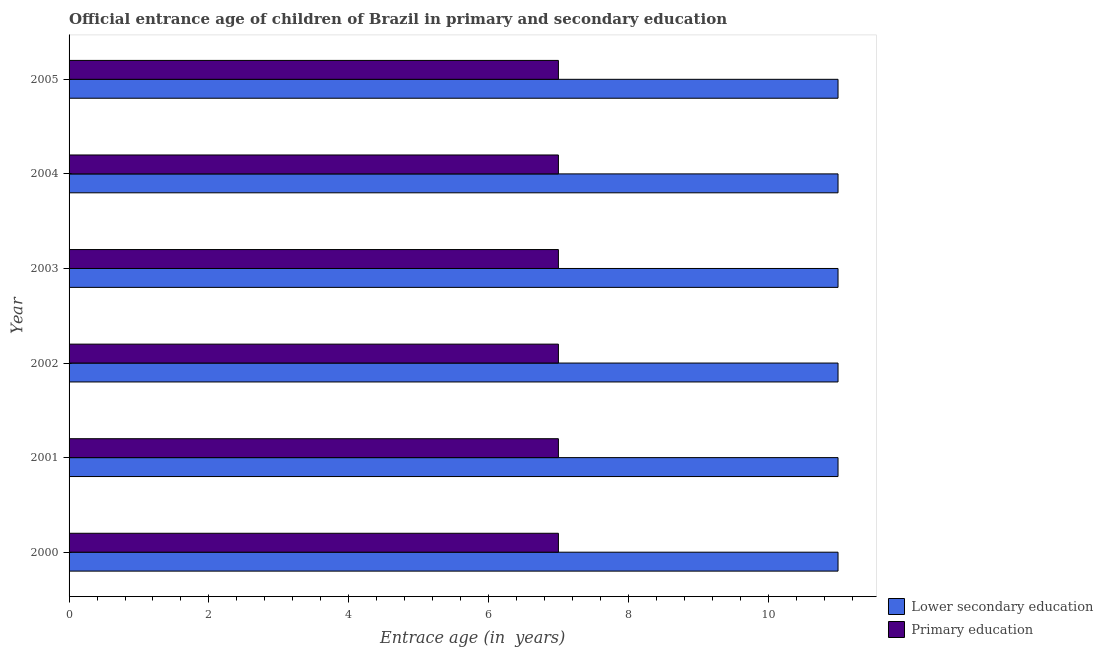How many different coloured bars are there?
Your response must be concise. 2. How many bars are there on the 5th tick from the top?
Offer a terse response. 2. How many bars are there on the 3rd tick from the bottom?
Keep it short and to the point. 2. In how many cases, is the number of bars for a given year not equal to the number of legend labels?
Your response must be concise. 0. What is the entrance age of chiildren in primary education in 2003?
Your answer should be very brief. 7. Across all years, what is the maximum entrance age of children in lower secondary education?
Your answer should be compact. 11. Across all years, what is the minimum entrance age of children in lower secondary education?
Provide a succinct answer. 11. In which year was the entrance age of children in lower secondary education maximum?
Keep it short and to the point. 2000. In which year was the entrance age of chiildren in primary education minimum?
Your answer should be compact. 2000. What is the total entrance age of children in lower secondary education in the graph?
Ensure brevity in your answer.  66. What is the difference between the entrance age of chiildren in primary education in 2001 and that in 2002?
Provide a succinct answer. 0. What is the difference between the entrance age of children in lower secondary education in 2000 and the entrance age of chiildren in primary education in 2004?
Make the answer very short. 4. What is the average entrance age of children in lower secondary education per year?
Your answer should be compact. 11. In the year 2005, what is the difference between the entrance age of children in lower secondary education and entrance age of chiildren in primary education?
Offer a very short reply. 4. In how many years, is the entrance age of chiildren in primary education greater than 2.4 years?
Provide a short and direct response. 6. Is the entrance age of chiildren in primary education in 2000 less than that in 2003?
Your response must be concise. No. What is the difference between the highest and the lowest entrance age of children in lower secondary education?
Make the answer very short. 0. How many years are there in the graph?
Offer a terse response. 6. What is the difference between two consecutive major ticks on the X-axis?
Your answer should be very brief. 2. Are the values on the major ticks of X-axis written in scientific E-notation?
Your response must be concise. No. Where does the legend appear in the graph?
Make the answer very short. Bottom right. How many legend labels are there?
Ensure brevity in your answer.  2. How are the legend labels stacked?
Provide a short and direct response. Vertical. What is the title of the graph?
Provide a succinct answer. Official entrance age of children of Brazil in primary and secondary education. What is the label or title of the X-axis?
Offer a terse response. Entrace age (in  years). What is the label or title of the Y-axis?
Your response must be concise. Year. What is the Entrace age (in  years) of Lower secondary education in 2000?
Give a very brief answer. 11. What is the Entrace age (in  years) in Primary education in 2002?
Provide a succinct answer. 7. What is the Entrace age (in  years) in Lower secondary education in 2003?
Your answer should be compact. 11. What is the Entrace age (in  years) in Primary education in 2003?
Your answer should be very brief. 7. Across all years, what is the maximum Entrace age (in  years) of Primary education?
Your response must be concise. 7. Across all years, what is the minimum Entrace age (in  years) of Lower secondary education?
Make the answer very short. 11. What is the total Entrace age (in  years) of Lower secondary education in the graph?
Keep it short and to the point. 66. What is the total Entrace age (in  years) in Primary education in the graph?
Make the answer very short. 42. What is the difference between the Entrace age (in  years) of Primary education in 2000 and that in 2001?
Your answer should be compact. 0. What is the difference between the Entrace age (in  years) of Primary education in 2000 and that in 2002?
Give a very brief answer. 0. What is the difference between the Entrace age (in  years) in Lower secondary education in 2000 and that in 2003?
Keep it short and to the point. 0. What is the difference between the Entrace age (in  years) of Primary education in 2000 and that in 2003?
Offer a very short reply. 0. What is the difference between the Entrace age (in  years) in Lower secondary education in 2000 and that in 2004?
Offer a very short reply. 0. What is the difference between the Entrace age (in  years) in Primary education in 2000 and that in 2005?
Give a very brief answer. 0. What is the difference between the Entrace age (in  years) in Primary education in 2001 and that in 2003?
Your response must be concise. 0. What is the difference between the Entrace age (in  years) of Lower secondary education in 2001 and that in 2005?
Provide a succinct answer. 0. What is the difference between the Entrace age (in  years) in Primary education in 2002 and that in 2003?
Your answer should be very brief. 0. What is the difference between the Entrace age (in  years) of Lower secondary education in 2003 and that in 2004?
Your answer should be compact. 0. What is the difference between the Entrace age (in  years) in Lower secondary education in 2003 and that in 2005?
Provide a succinct answer. 0. What is the difference between the Entrace age (in  years) in Lower secondary education in 2001 and the Entrace age (in  years) in Primary education in 2002?
Offer a very short reply. 4. What is the difference between the Entrace age (in  years) of Lower secondary education in 2001 and the Entrace age (in  years) of Primary education in 2005?
Keep it short and to the point. 4. What is the difference between the Entrace age (in  years) of Lower secondary education in 2002 and the Entrace age (in  years) of Primary education in 2003?
Your answer should be very brief. 4. What is the difference between the Entrace age (in  years) of Lower secondary education in 2002 and the Entrace age (in  years) of Primary education in 2004?
Your answer should be compact. 4. What is the difference between the Entrace age (in  years) in Lower secondary education in 2002 and the Entrace age (in  years) in Primary education in 2005?
Your response must be concise. 4. What is the difference between the Entrace age (in  years) in Lower secondary education in 2003 and the Entrace age (in  years) in Primary education in 2004?
Your response must be concise. 4. What is the difference between the Entrace age (in  years) in Lower secondary education in 2003 and the Entrace age (in  years) in Primary education in 2005?
Keep it short and to the point. 4. What is the difference between the Entrace age (in  years) in Lower secondary education in 2004 and the Entrace age (in  years) in Primary education in 2005?
Provide a short and direct response. 4. What is the average Entrace age (in  years) in Primary education per year?
Ensure brevity in your answer.  7. In the year 2002, what is the difference between the Entrace age (in  years) of Lower secondary education and Entrace age (in  years) of Primary education?
Your answer should be very brief. 4. In the year 2003, what is the difference between the Entrace age (in  years) of Lower secondary education and Entrace age (in  years) of Primary education?
Provide a short and direct response. 4. In the year 2004, what is the difference between the Entrace age (in  years) of Lower secondary education and Entrace age (in  years) of Primary education?
Keep it short and to the point. 4. What is the ratio of the Entrace age (in  years) of Lower secondary education in 2000 to that in 2002?
Provide a succinct answer. 1. What is the ratio of the Entrace age (in  years) in Lower secondary education in 2000 to that in 2003?
Give a very brief answer. 1. What is the ratio of the Entrace age (in  years) in Lower secondary education in 2000 to that in 2004?
Give a very brief answer. 1. What is the ratio of the Entrace age (in  years) in Primary education in 2000 to that in 2004?
Offer a terse response. 1. What is the ratio of the Entrace age (in  years) in Lower secondary education in 2001 to that in 2002?
Make the answer very short. 1. What is the ratio of the Entrace age (in  years) of Lower secondary education in 2001 to that in 2004?
Your response must be concise. 1. What is the ratio of the Entrace age (in  years) of Primary education in 2001 to that in 2004?
Give a very brief answer. 1. What is the ratio of the Entrace age (in  years) in Lower secondary education in 2002 to that in 2004?
Provide a succinct answer. 1. What is the ratio of the Entrace age (in  years) of Lower secondary education in 2002 to that in 2005?
Provide a succinct answer. 1. What is the ratio of the Entrace age (in  years) of Lower secondary education in 2003 to that in 2004?
Ensure brevity in your answer.  1. What is the ratio of the Entrace age (in  years) in Primary education in 2003 to that in 2004?
Provide a short and direct response. 1. What is the ratio of the Entrace age (in  years) in Primary education in 2003 to that in 2005?
Your answer should be compact. 1. What is the difference between the highest and the second highest Entrace age (in  years) of Lower secondary education?
Offer a very short reply. 0. What is the difference between the highest and the lowest Entrace age (in  years) of Lower secondary education?
Make the answer very short. 0. 